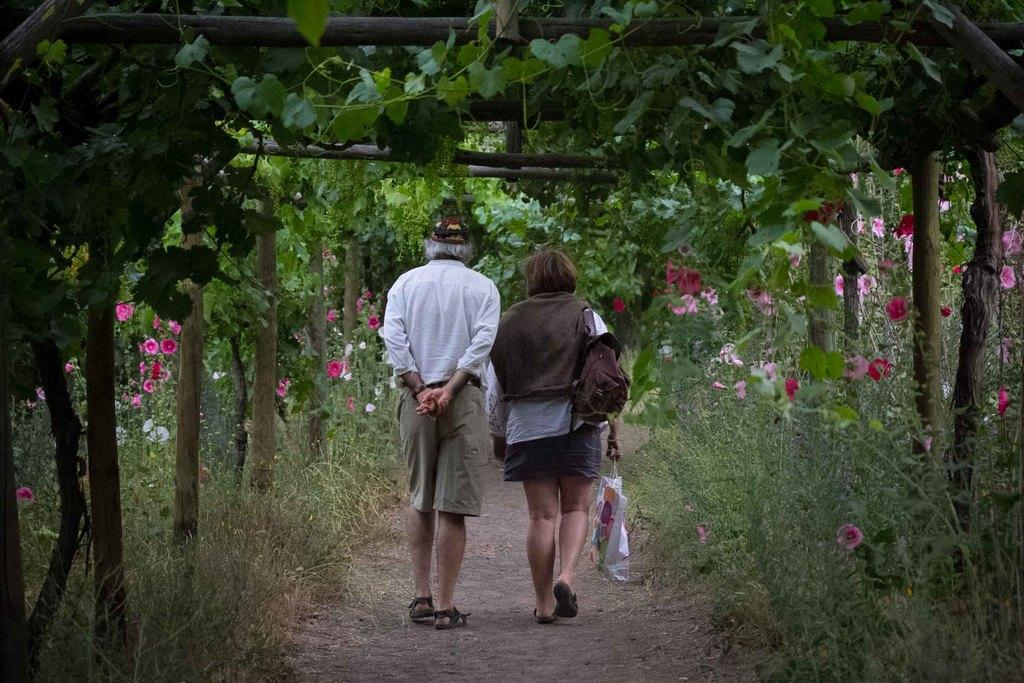What are the two persons in the image doing? The two persons in the image are walking. What is the woman wearing that is visible in the image? The woman is wearing a bag. What is the woman holding in the image? The woman is holding a cover. What type of vegetation can be seen on the right side of the image? There are trees on the right side of the image, and they have flowers associated with them. What type of vegetation can be seen on the left side of the image? There are trees on the left side of the image, and they have flowers associated with them. What type of bread can be seen in the image? There is no bread present in the image. Can you describe the bat that is flying in the image? There is no bat present in the image. 